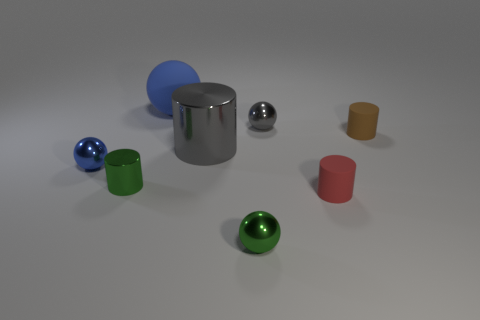Subtract 1 spheres. How many spheres are left? 3 Add 1 large blue rubber things. How many objects exist? 9 Subtract all green shiny objects. Subtract all blue things. How many objects are left? 4 Add 6 tiny spheres. How many tiny spheres are left? 9 Add 3 big purple blocks. How many big purple blocks exist? 3 Subtract 0 yellow balls. How many objects are left? 8 